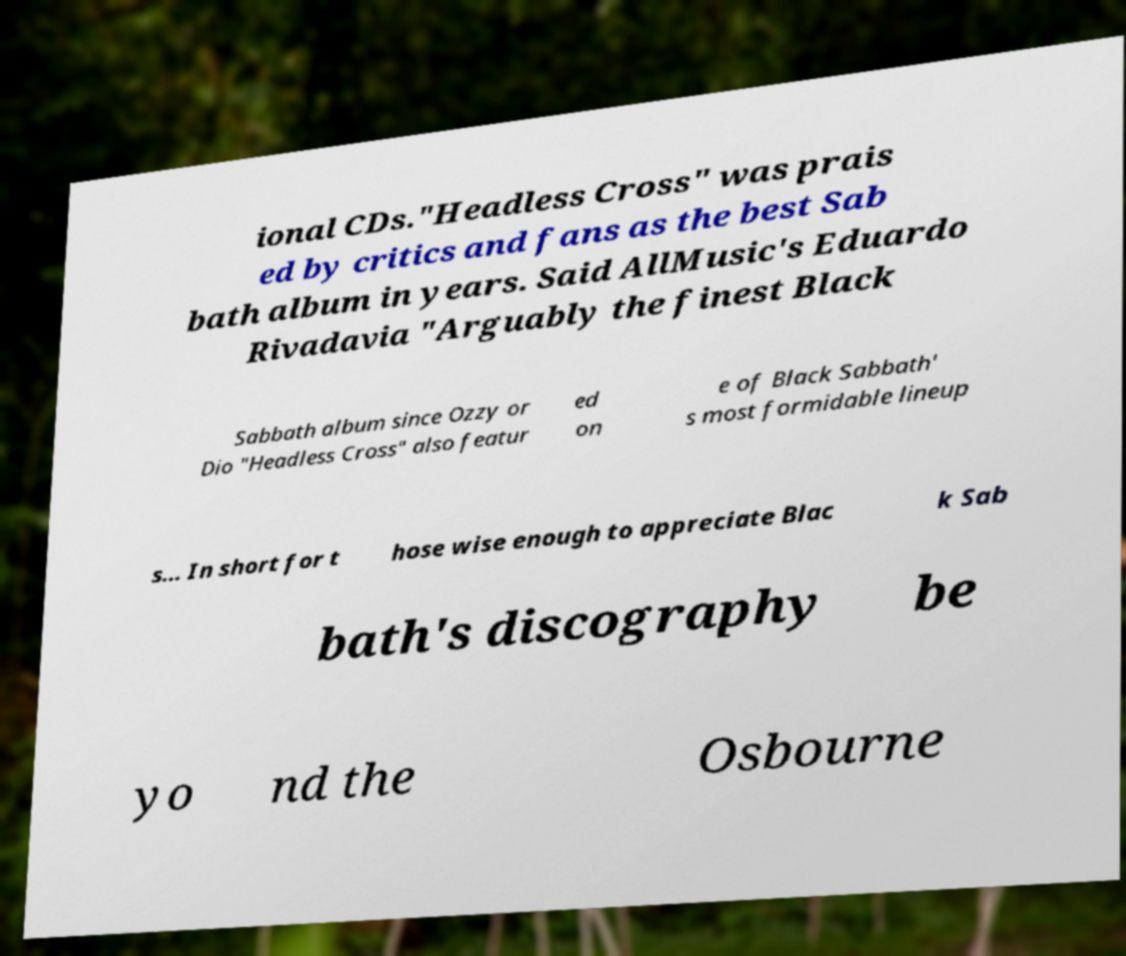Please read and relay the text visible in this image. What does it say? ional CDs."Headless Cross" was prais ed by critics and fans as the best Sab bath album in years. Said AllMusic's Eduardo Rivadavia "Arguably the finest Black Sabbath album since Ozzy or Dio "Headless Cross" also featur ed on e of Black Sabbath' s most formidable lineup s... In short for t hose wise enough to appreciate Blac k Sab bath's discography be yo nd the Osbourne 